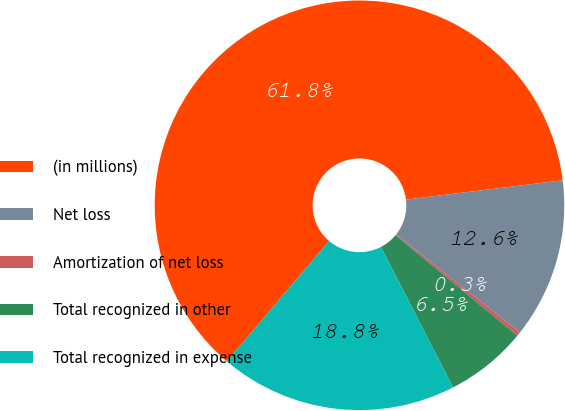<chart> <loc_0><loc_0><loc_500><loc_500><pie_chart><fcel>(in millions)<fcel>Net loss<fcel>Amortization of net loss<fcel>Total recognized in other<fcel>Total recognized in expense<nl><fcel>61.85%<fcel>12.62%<fcel>0.31%<fcel>6.46%<fcel>18.77%<nl></chart> 